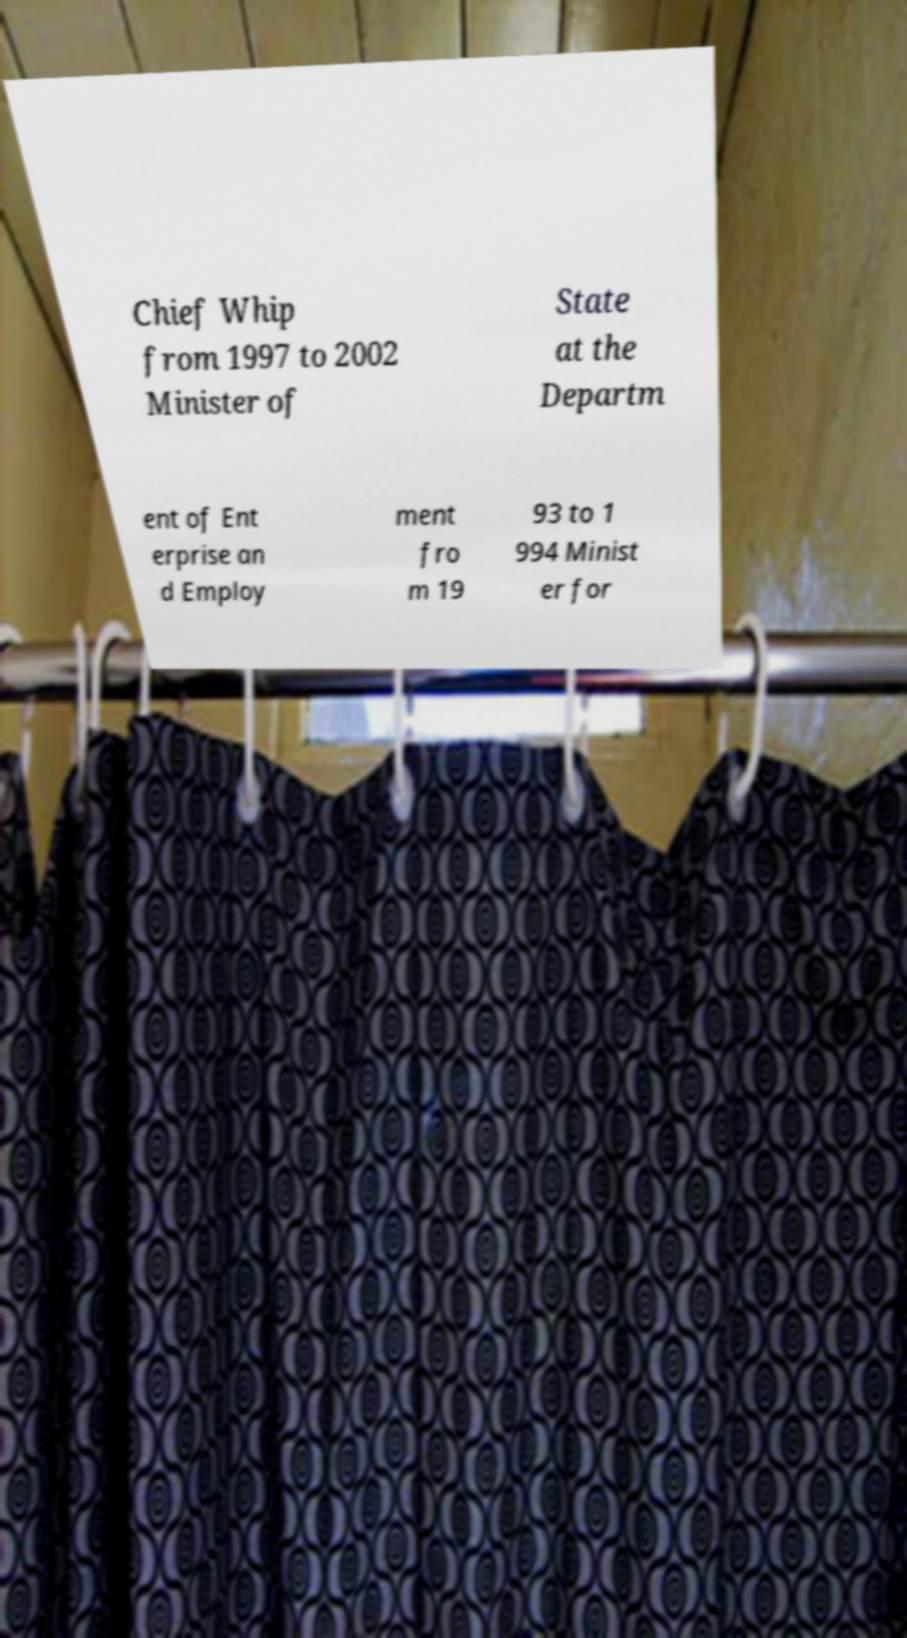Please identify and transcribe the text found in this image. Chief Whip from 1997 to 2002 Minister of State at the Departm ent of Ent erprise an d Employ ment fro m 19 93 to 1 994 Minist er for 